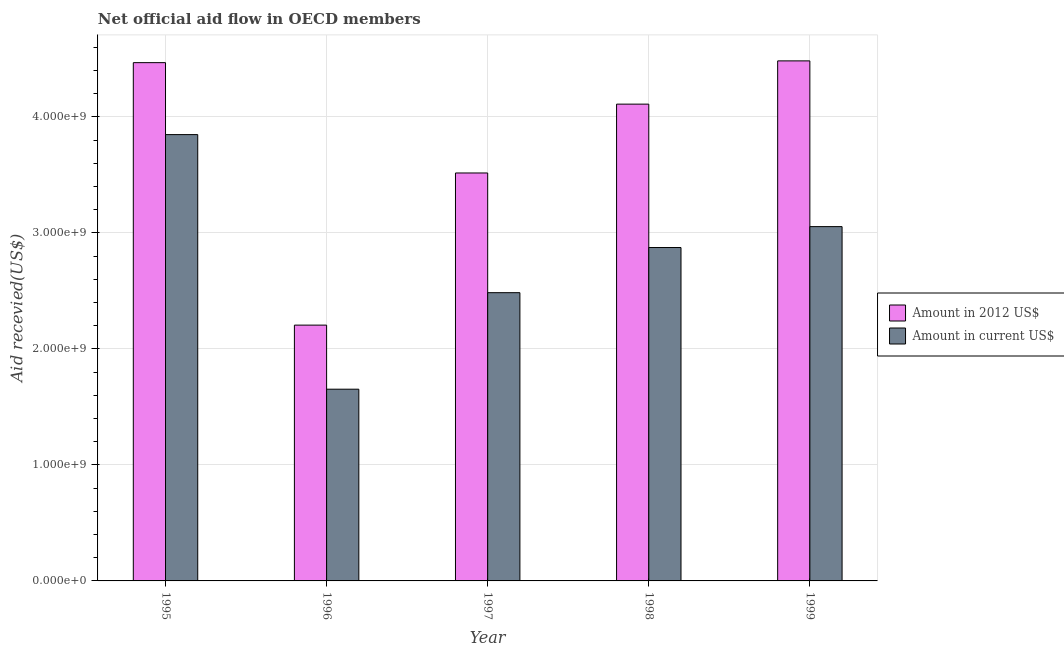How many groups of bars are there?
Provide a succinct answer. 5. Are the number of bars on each tick of the X-axis equal?
Keep it short and to the point. Yes. How many bars are there on the 4th tick from the left?
Provide a short and direct response. 2. How many bars are there on the 2nd tick from the right?
Ensure brevity in your answer.  2. What is the amount of aid received(expressed in 2012 us$) in 1998?
Make the answer very short. 4.11e+09. Across all years, what is the maximum amount of aid received(expressed in us$)?
Your response must be concise. 3.85e+09. Across all years, what is the minimum amount of aid received(expressed in 2012 us$)?
Your answer should be compact. 2.20e+09. In which year was the amount of aid received(expressed in 2012 us$) maximum?
Your answer should be very brief. 1999. What is the total amount of aid received(expressed in us$) in the graph?
Your response must be concise. 1.39e+1. What is the difference between the amount of aid received(expressed in us$) in 1995 and that in 1997?
Provide a short and direct response. 1.36e+09. What is the difference between the amount of aid received(expressed in 2012 us$) in 1996 and the amount of aid received(expressed in us$) in 1995?
Give a very brief answer. -2.26e+09. What is the average amount of aid received(expressed in us$) per year?
Ensure brevity in your answer.  2.78e+09. In the year 1999, what is the difference between the amount of aid received(expressed in us$) and amount of aid received(expressed in 2012 us$)?
Keep it short and to the point. 0. In how many years, is the amount of aid received(expressed in us$) greater than 3600000000 US$?
Offer a terse response. 1. What is the ratio of the amount of aid received(expressed in 2012 us$) in 1998 to that in 1999?
Your answer should be compact. 0.92. Is the difference between the amount of aid received(expressed in 2012 us$) in 1997 and 1999 greater than the difference between the amount of aid received(expressed in us$) in 1997 and 1999?
Keep it short and to the point. No. What is the difference between the highest and the second highest amount of aid received(expressed in us$)?
Ensure brevity in your answer.  7.93e+08. What is the difference between the highest and the lowest amount of aid received(expressed in us$)?
Provide a short and direct response. 2.19e+09. In how many years, is the amount of aid received(expressed in us$) greater than the average amount of aid received(expressed in us$) taken over all years?
Ensure brevity in your answer.  3. What does the 2nd bar from the left in 1999 represents?
Keep it short and to the point. Amount in current US$. What does the 1st bar from the right in 1999 represents?
Keep it short and to the point. Amount in current US$. Does the graph contain grids?
Your answer should be compact. Yes. What is the title of the graph?
Keep it short and to the point. Net official aid flow in OECD members. What is the label or title of the X-axis?
Offer a terse response. Year. What is the label or title of the Y-axis?
Ensure brevity in your answer.  Aid recevied(US$). What is the Aid recevied(US$) in Amount in 2012 US$ in 1995?
Ensure brevity in your answer.  4.47e+09. What is the Aid recevied(US$) in Amount in current US$ in 1995?
Give a very brief answer. 3.85e+09. What is the Aid recevied(US$) in Amount in 2012 US$ in 1996?
Your answer should be compact. 2.20e+09. What is the Aid recevied(US$) of Amount in current US$ in 1996?
Your answer should be very brief. 1.65e+09. What is the Aid recevied(US$) in Amount in 2012 US$ in 1997?
Make the answer very short. 3.52e+09. What is the Aid recevied(US$) in Amount in current US$ in 1997?
Your answer should be compact. 2.48e+09. What is the Aid recevied(US$) in Amount in 2012 US$ in 1998?
Provide a short and direct response. 4.11e+09. What is the Aid recevied(US$) in Amount in current US$ in 1998?
Your answer should be very brief. 2.87e+09. What is the Aid recevied(US$) of Amount in 2012 US$ in 1999?
Keep it short and to the point. 4.48e+09. What is the Aid recevied(US$) of Amount in current US$ in 1999?
Your response must be concise. 3.05e+09. Across all years, what is the maximum Aid recevied(US$) of Amount in 2012 US$?
Your response must be concise. 4.48e+09. Across all years, what is the maximum Aid recevied(US$) of Amount in current US$?
Your answer should be compact. 3.85e+09. Across all years, what is the minimum Aid recevied(US$) of Amount in 2012 US$?
Offer a terse response. 2.20e+09. Across all years, what is the minimum Aid recevied(US$) in Amount in current US$?
Ensure brevity in your answer.  1.65e+09. What is the total Aid recevied(US$) of Amount in 2012 US$ in the graph?
Provide a succinct answer. 1.88e+1. What is the total Aid recevied(US$) in Amount in current US$ in the graph?
Ensure brevity in your answer.  1.39e+1. What is the difference between the Aid recevied(US$) in Amount in 2012 US$ in 1995 and that in 1996?
Ensure brevity in your answer.  2.26e+09. What is the difference between the Aid recevied(US$) in Amount in current US$ in 1995 and that in 1996?
Make the answer very short. 2.19e+09. What is the difference between the Aid recevied(US$) of Amount in 2012 US$ in 1995 and that in 1997?
Your response must be concise. 9.51e+08. What is the difference between the Aid recevied(US$) in Amount in current US$ in 1995 and that in 1997?
Your response must be concise. 1.36e+09. What is the difference between the Aid recevied(US$) in Amount in 2012 US$ in 1995 and that in 1998?
Ensure brevity in your answer.  3.58e+08. What is the difference between the Aid recevied(US$) in Amount in current US$ in 1995 and that in 1998?
Your answer should be very brief. 9.73e+08. What is the difference between the Aid recevied(US$) in Amount in 2012 US$ in 1995 and that in 1999?
Provide a short and direct response. -1.53e+07. What is the difference between the Aid recevied(US$) of Amount in current US$ in 1995 and that in 1999?
Your answer should be compact. 7.93e+08. What is the difference between the Aid recevied(US$) in Amount in 2012 US$ in 1996 and that in 1997?
Your response must be concise. -1.31e+09. What is the difference between the Aid recevied(US$) of Amount in current US$ in 1996 and that in 1997?
Keep it short and to the point. -8.32e+08. What is the difference between the Aid recevied(US$) of Amount in 2012 US$ in 1996 and that in 1998?
Offer a very short reply. -1.90e+09. What is the difference between the Aid recevied(US$) in Amount in current US$ in 1996 and that in 1998?
Offer a terse response. -1.22e+09. What is the difference between the Aid recevied(US$) in Amount in 2012 US$ in 1996 and that in 1999?
Provide a short and direct response. -2.28e+09. What is the difference between the Aid recevied(US$) in Amount in current US$ in 1996 and that in 1999?
Ensure brevity in your answer.  -1.40e+09. What is the difference between the Aid recevied(US$) of Amount in 2012 US$ in 1997 and that in 1998?
Your response must be concise. -5.93e+08. What is the difference between the Aid recevied(US$) in Amount in current US$ in 1997 and that in 1998?
Give a very brief answer. -3.89e+08. What is the difference between the Aid recevied(US$) of Amount in 2012 US$ in 1997 and that in 1999?
Keep it short and to the point. -9.66e+08. What is the difference between the Aid recevied(US$) in Amount in current US$ in 1997 and that in 1999?
Ensure brevity in your answer.  -5.70e+08. What is the difference between the Aid recevied(US$) in Amount in 2012 US$ in 1998 and that in 1999?
Give a very brief answer. -3.73e+08. What is the difference between the Aid recevied(US$) of Amount in current US$ in 1998 and that in 1999?
Offer a very short reply. -1.80e+08. What is the difference between the Aid recevied(US$) of Amount in 2012 US$ in 1995 and the Aid recevied(US$) of Amount in current US$ in 1996?
Make the answer very short. 2.81e+09. What is the difference between the Aid recevied(US$) in Amount in 2012 US$ in 1995 and the Aid recevied(US$) in Amount in current US$ in 1997?
Keep it short and to the point. 1.98e+09. What is the difference between the Aid recevied(US$) in Amount in 2012 US$ in 1995 and the Aid recevied(US$) in Amount in current US$ in 1998?
Your answer should be compact. 1.59e+09. What is the difference between the Aid recevied(US$) in Amount in 2012 US$ in 1995 and the Aid recevied(US$) in Amount in current US$ in 1999?
Keep it short and to the point. 1.41e+09. What is the difference between the Aid recevied(US$) in Amount in 2012 US$ in 1996 and the Aid recevied(US$) in Amount in current US$ in 1997?
Give a very brief answer. -2.80e+08. What is the difference between the Aid recevied(US$) of Amount in 2012 US$ in 1996 and the Aid recevied(US$) of Amount in current US$ in 1998?
Your response must be concise. -6.69e+08. What is the difference between the Aid recevied(US$) in Amount in 2012 US$ in 1996 and the Aid recevied(US$) in Amount in current US$ in 1999?
Provide a succinct answer. -8.49e+08. What is the difference between the Aid recevied(US$) of Amount in 2012 US$ in 1997 and the Aid recevied(US$) of Amount in current US$ in 1998?
Your answer should be very brief. 6.43e+08. What is the difference between the Aid recevied(US$) of Amount in 2012 US$ in 1997 and the Aid recevied(US$) of Amount in current US$ in 1999?
Make the answer very short. 4.62e+08. What is the difference between the Aid recevied(US$) of Amount in 2012 US$ in 1998 and the Aid recevied(US$) of Amount in current US$ in 1999?
Keep it short and to the point. 1.06e+09. What is the average Aid recevied(US$) of Amount in 2012 US$ per year?
Give a very brief answer. 3.76e+09. What is the average Aid recevied(US$) of Amount in current US$ per year?
Offer a terse response. 2.78e+09. In the year 1995, what is the difference between the Aid recevied(US$) of Amount in 2012 US$ and Aid recevied(US$) of Amount in current US$?
Your response must be concise. 6.20e+08. In the year 1996, what is the difference between the Aid recevied(US$) of Amount in 2012 US$ and Aid recevied(US$) of Amount in current US$?
Your answer should be very brief. 5.52e+08. In the year 1997, what is the difference between the Aid recevied(US$) of Amount in 2012 US$ and Aid recevied(US$) of Amount in current US$?
Your answer should be compact. 1.03e+09. In the year 1998, what is the difference between the Aid recevied(US$) of Amount in 2012 US$ and Aid recevied(US$) of Amount in current US$?
Your response must be concise. 1.24e+09. In the year 1999, what is the difference between the Aid recevied(US$) of Amount in 2012 US$ and Aid recevied(US$) of Amount in current US$?
Offer a terse response. 1.43e+09. What is the ratio of the Aid recevied(US$) in Amount in 2012 US$ in 1995 to that in 1996?
Offer a terse response. 2.03. What is the ratio of the Aid recevied(US$) of Amount in current US$ in 1995 to that in 1996?
Ensure brevity in your answer.  2.33. What is the ratio of the Aid recevied(US$) of Amount in 2012 US$ in 1995 to that in 1997?
Keep it short and to the point. 1.27. What is the ratio of the Aid recevied(US$) in Amount in current US$ in 1995 to that in 1997?
Keep it short and to the point. 1.55. What is the ratio of the Aid recevied(US$) in Amount in 2012 US$ in 1995 to that in 1998?
Your response must be concise. 1.09. What is the ratio of the Aid recevied(US$) in Amount in current US$ in 1995 to that in 1998?
Ensure brevity in your answer.  1.34. What is the ratio of the Aid recevied(US$) of Amount in 2012 US$ in 1995 to that in 1999?
Your answer should be compact. 1. What is the ratio of the Aid recevied(US$) of Amount in current US$ in 1995 to that in 1999?
Your answer should be compact. 1.26. What is the ratio of the Aid recevied(US$) in Amount in 2012 US$ in 1996 to that in 1997?
Give a very brief answer. 0.63. What is the ratio of the Aid recevied(US$) in Amount in current US$ in 1996 to that in 1997?
Offer a terse response. 0.67. What is the ratio of the Aid recevied(US$) in Amount in 2012 US$ in 1996 to that in 1998?
Offer a very short reply. 0.54. What is the ratio of the Aid recevied(US$) in Amount in current US$ in 1996 to that in 1998?
Provide a succinct answer. 0.58. What is the ratio of the Aid recevied(US$) in Amount in 2012 US$ in 1996 to that in 1999?
Offer a very short reply. 0.49. What is the ratio of the Aid recevied(US$) in Amount in current US$ in 1996 to that in 1999?
Make the answer very short. 0.54. What is the ratio of the Aid recevied(US$) in Amount in 2012 US$ in 1997 to that in 1998?
Your response must be concise. 0.86. What is the ratio of the Aid recevied(US$) of Amount in current US$ in 1997 to that in 1998?
Ensure brevity in your answer.  0.86. What is the ratio of the Aid recevied(US$) of Amount in 2012 US$ in 1997 to that in 1999?
Offer a terse response. 0.78. What is the ratio of the Aid recevied(US$) of Amount in current US$ in 1997 to that in 1999?
Make the answer very short. 0.81. What is the ratio of the Aid recevied(US$) in Amount in 2012 US$ in 1998 to that in 1999?
Ensure brevity in your answer.  0.92. What is the ratio of the Aid recevied(US$) in Amount in current US$ in 1998 to that in 1999?
Ensure brevity in your answer.  0.94. What is the difference between the highest and the second highest Aid recevied(US$) in Amount in 2012 US$?
Provide a succinct answer. 1.53e+07. What is the difference between the highest and the second highest Aid recevied(US$) in Amount in current US$?
Offer a terse response. 7.93e+08. What is the difference between the highest and the lowest Aid recevied(US$) in Amount in 2012 US$?
Your answer should be very brief. 2.28e+09. What is the difference between the highest and the lowest Aid recevied(US$) in Amount in current US$?
Offer a terse response. 2.19e+09. 